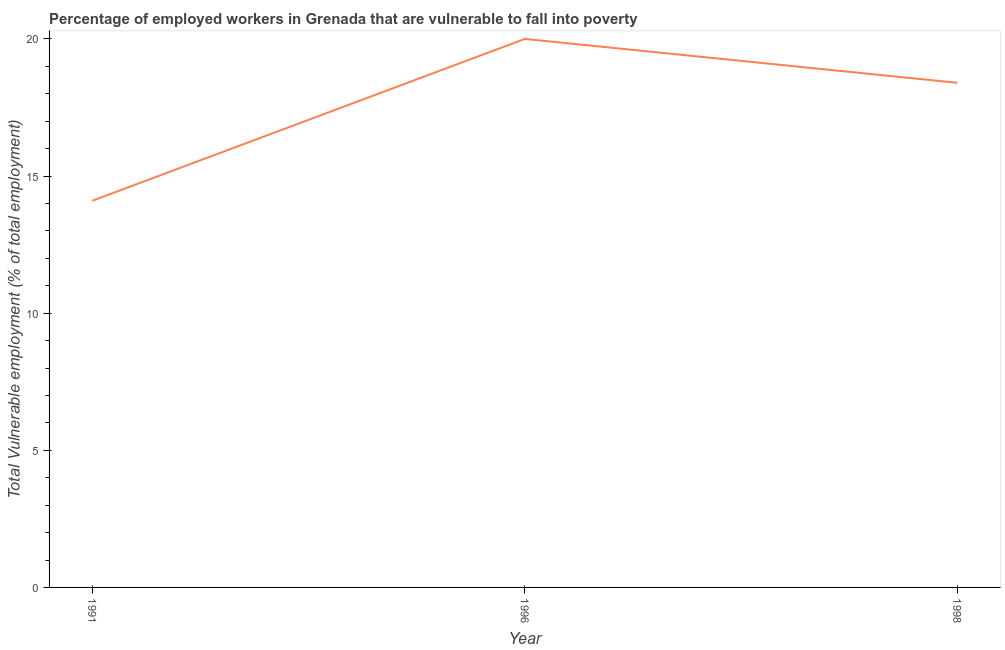What is the total vulnerable employment in 1998?
Keep it short and to the point. 18.4. Across all years, what is the minimum total vulnerable employment?
Keep it short and to the point. 14.1. In which year was the total vulnerable employment maximum?
Give a very brief answer. 1996. What is the sum of the total vulnerable employment?
Provide a succinct answer. 52.5. What is the difference between the total vulnerable employment in 1996 and 1998?
Your answer should be compact. 1.6. What is the median total vulnerable employment?
Ensure brevity in your answer.  18.4. In how many years, is the total vulnerable employment greater than 17 %?
Provide a short and direct response. 2. Do a majority of the years between 1998 and 1996 (inclusive) have total vulnerable employment greater than 1 %?
Offer a terse response. No. What is the ratio of the total vulnerable employment in 1991 to that in 1998?
Give a very brief answer. 0.77. What is the difference between the highest and the second highest total vulnerable employment?
Your answer should be very brief. 1.6. Is the sum of the total vulnerable employment in 1991 and 1996 greater than the maximum total vulnerable employment across all years?
Ensure brevity in your answer.  Yes. What is the difference between the highest and the lowest total vulnerable employment?
Provide a succinct answer. 5.9. How many lines are there?
Make the answer very short. 1. How many years are there in the graph?
Keep it short and to the point. 3. What is the difference between two consecutive major ticks on the Y-axis?
Make the answer very short. 5. Are the values on the major ticks of Y-axis written in scientific E-notation?
Provide a short and direct response. No. What is the title of the graph?
Make the answer very short. Percentage of employed workers in Grenada that are vulnerable to fall into poverty. What is the label or title of the Y-axis?
Your response must be concise. Total Vulnerable employment (% of total employment). What is the Total Vulnerable employment (% of total employment) in 1991?
Your response must be concise. 14.1. What is the Total Vulnerable employment (% of total employment) in 1996?
Make the answer very short. 20. What is the Total Vulnerable employment (% of total employment) of 1998?
Keep it short and to the point. 18.4. What is the ratio of the Total Vulnerable employment (% of total employment) in 1991 to that in 1996?
Offer a terse response. 0.7. What is the ratio of the Total Vulnerable employment (% of total employment) in 1991 to that in 1998?
Make the answer very short. 0.77. What is the ratio of the Total Vulnerable employment (% of total employment) in 1996 to that in 1998?
Your answer should be compact. 1.09. 